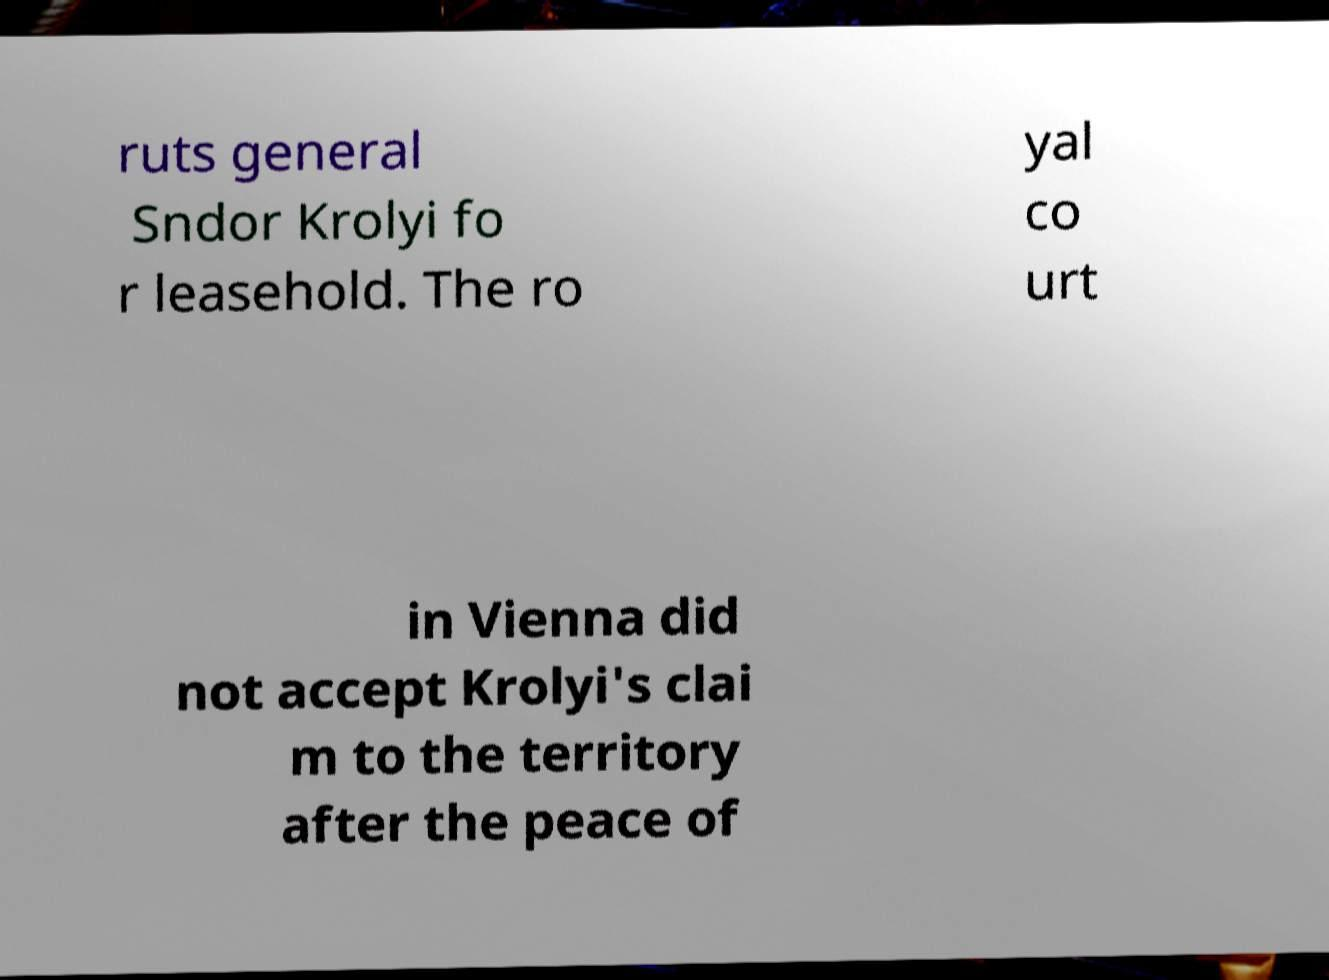Please identify and transcribe the text found in this image. ruts general Sndor Krolyi fo r leasehold. The ro yal co urt in Vienna did not accept Krolyi's clai m to the territory after the peace of 